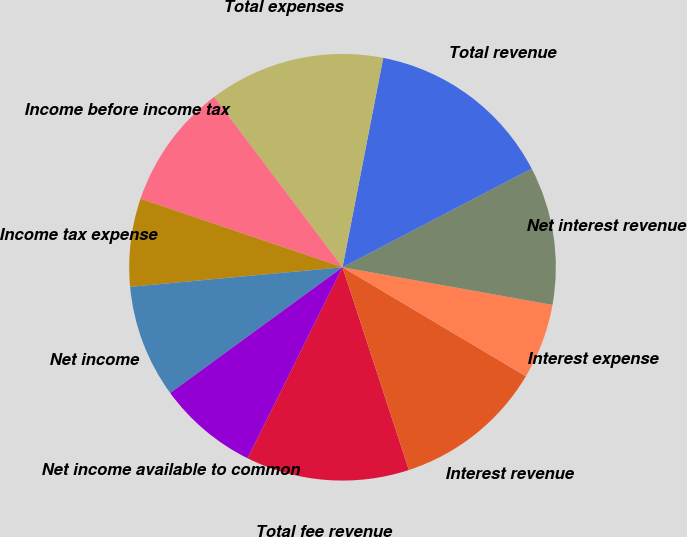<chart> <loc_0><loc_0><loc_500><loc_500><pie_chart><fcel>Total fee revenue<fcel>Interest revenue<fcel>Interest expense<fcel>Net interest revenue<fcel>Total revenue<fcel>Total expenses<fcel>Income before income tax<fcel>Income tax expense<fcel>Net income<fcel>Net income available to common<nl><fcel>12.38%<fcel>11.43%<fcel>5.71%<fcel>10.48%<fcel>14.29%<fcel>13.33%<fcel>9.52%<fcel>6.67%<fcel>8.57%<fcel>7.62%<nl></chart> 